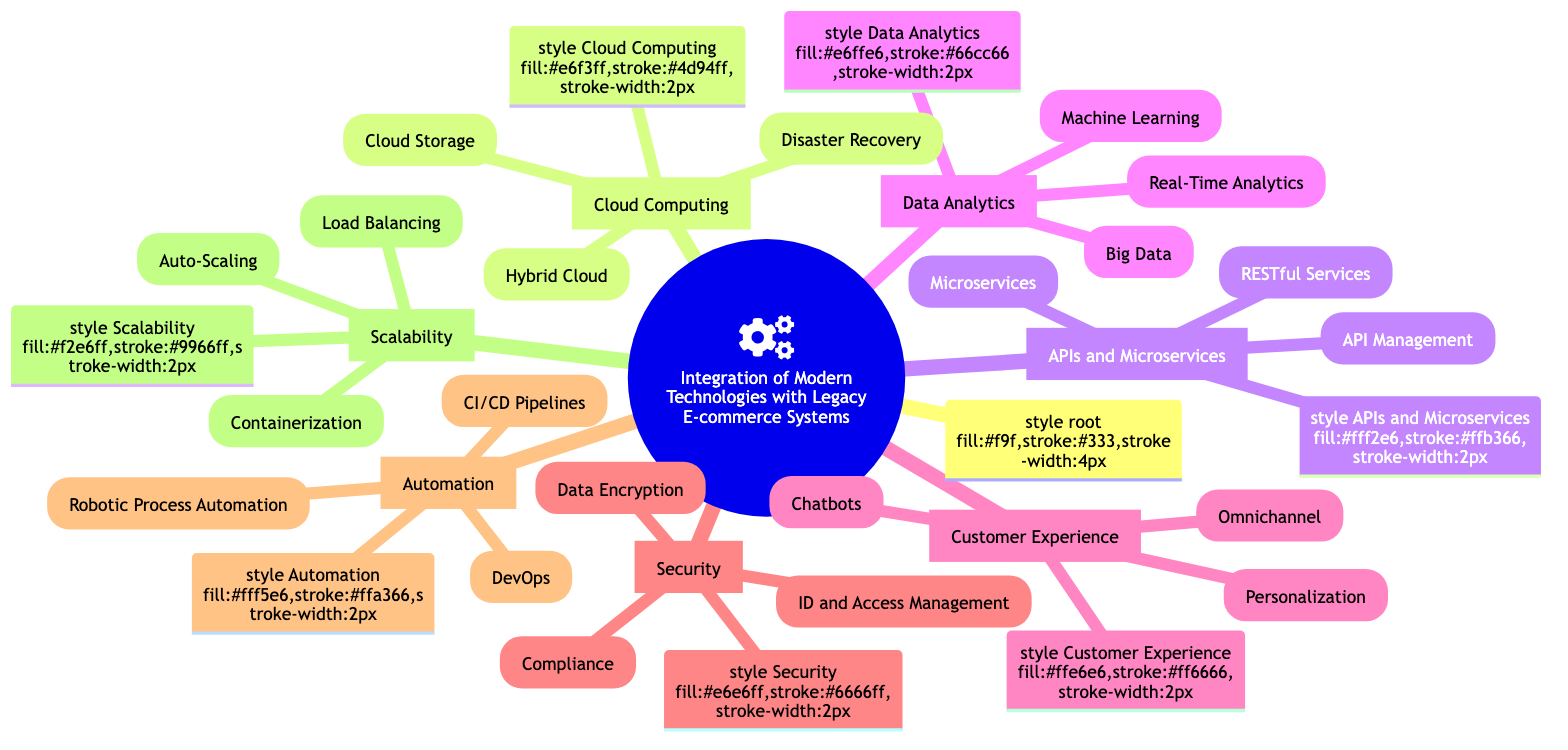What is the first main category in the diagram? The diagram's top-level node is titled "Integration of Modern Technologies with Legacy E-commerce Systems," and the first main branch after it is "Cloud Computing."
Answer: Cloud Computing How many main categories are represented in the diagram? Counting the main branches emanating from the root node, we find a total of six categories: Cloud Computing, APIs and Microservices, Data Analytics, Customer Experience, Security, Automation, and Scalability.
Answer: 6 Which category includes "Personalization"? "Personalization" is found under the "Customer Experience" category, which is a main branch of the diagram.
Answer: Customer Experience What modern technology does the "Hybrid Cloud" node represent? The "Hybrid Cloud" node indicates a combination of on-premises servers with public cloud services like AWS, Azure, or Google Cloud.
Answer: Combining on-premises servers with public cloud services In which category is "Data Encryption" located? “Data Encryption” appears under the "Security" category of the diagram, which suggests its relevance to protecting data.
Answer: Security How many nodes are under the "Automation" category? There are three nodes listed under the "Automation" category: Robotic Process Automation, CI/CD Pipelines, and DevOps, indicating various aspects of automation practices.
Answer: 3 What is the relationship between "RESTful Services" and "APIs and Microservices"? "RESTful Services" is one of the three nodes under the "APIs and Microservices" category, indicating that it is a type of integration method used within that framework.
Answer: Type of integration method within that framework Which technology is used for real-time data insights? "Real-Time Analytics" is the specific node that focuses on using stream processing platforms like Apache Kafka for gaining real-time insights into data, indicating its application in analytics.
Answer: Using stream processing platforms like Apache Kafka Which category contains features for user authentication? The feature for user authentication can be found under the "Security" category, which includes the implementation of modern Identity and Access Management solutions.
Answer: Security 